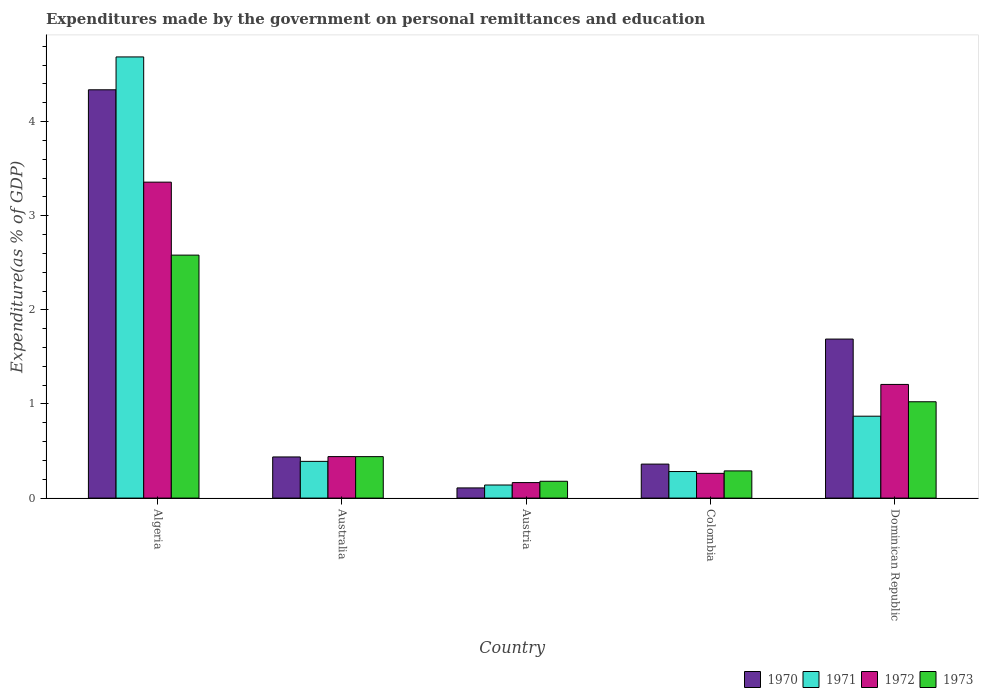Are the number of bars on each tick of the X-axis equal?
Provide a short and direct response. Yes. How many bars are there on the 1st tick from the left?
Offer a terse response. 4. In how many cases, is the number of bars for a given country not equal to the number of legend labels?
Make the answer very short. 0. What is the expenditures made by the government on personal remittances and education in 1971 in Colombia?
Your response must be concise. 0.28. Across all countries, what is the maximum expenditures made by the government on personal remittances and education in 1971?
Give a very brief answer. 4.69. Across all countries, what is the minimum expenditures made by the government on personal remittances and education in 1972?
Keep it short and to the point. 0.16. In which country was the expenditures made by the government on personal remittances and education in 1971 maximum?
Make the answer very short. Algeria. In which country was the expenditures made by the government on personal remittances and education in 1972 minimum?
Provide a succinct answer. Austria. What is the total expenditures made by the government on personal remittances and education in 1971 in the graph?
Give a very brief answer. 6.37. What is the difference between the expenditures made by the government on personal remittances and education in 1970 in Austria and that in Dominican Republic?
Offer a very short reply. -1.58. What is the difference between the expenditures made by the government on personal remittances and education in 1971 in Algeria and the expenditures made by the government on personal remittances and education in 1973 in Australia?
Keep it short and to the point. 4.25. What is the average expenditures made by the government on personal remittances and education in 1972 per country?
Make the answer very short. 1.09. What is the difference between the expenditures made by the government on personal remittances and education of/in 1970 and expenditures made by the government on personal remittances and education of/in 1972 in Algeria?
Give a very brief answer. 0.98. In how many countries, is the expenditures made by the government on personal remittances and education in 1971 greater than 3.6 %?
Provide a short and direct response. 1. What is the ratio of the expenditures made by the government on personal remittances and education in 1970 in Algeria to that in Dominican Republic?
Provide a short and direct response. 2.57. Is the expenditures made by the government on personal remittances and education in 1971 in Australia less than that in Colombia?
Give a very brief answer. No. Is the difference between the expenditures made by the government on personal remittances and education in 1970 in Algeria and Austria greater than the difference between the expenditures made by the government on personal remittances and education in 1972 in Algeria and Austria?
Ensure brevity in your answer.  Yes. What is the difference between the highest and the second highest expenditures made by the government on personal remittances and education in 1972?
Give a very brief answer. -0.77. What is the difference between the highest and the lowest expenditures made by the government on personal remittances and education in 1972?
Provide a succinct answer. 3.19. Is the sum of the expenditures made by the government on personal remittances and education in 1973 in Colombia and Dominican Republic greater than the maximum expenditures made by the government on personal remittances and education in 1970 across all countries?
Ensure brevity in your answer.  No. Is it the case that in every country, the sum of the expenditures made by the government on personal remittances and education in 1972 and expenditures made by the government on personal remittances and education in 1970 is greater than the expenditures made by the government on personal remittances and education in 1973?
Give a very brief answer. Yes. Are all the bars in the graph horizontal?
Your answer should be very brief. No. What is the difference between two consecutive major ticks on the Y-axis?
Offer a very short reply. 1. Does the graph contain any zero values?
Give a very brief answer. No. Does the graph contain grids?
Keep it short and to the point. No. How are the legend labels stacked?
Provide a succinct answer. Horizontal. What is the title of the graph?
Your response must be concise. Expenditures made by the government on personal remittances and education. What is the label or title of the X-axis?
Your answer should be very brief. Country. What is the label or title of the Y-axis?
Keep it short and to the point. Expenditure(as % of GDP). What is the Expenditure(as % of GDP) in 1970 in Algeria?
Provide a short and direct response. 4.34. What is the Expenditure(as % of GDP) in 1971 in Algeria?
Make the answer very short. 4.69. What is the Expenditure(as % of GDP) in 1972 in Algeria?
Offer a terse response. 3.36. What is the Expenditure(as % of GDP) in 1973 in Algeria?
Make the answer very short. 2.58. What is the Expenditure(as % of GDP) in 1970 in Australia?
Offer a terse response. 0.44. What is the Expenditure(as % of GDP) of 1971 in Australia?
Offer a terse response. 0.39. What is the Expenditure(as % of GDP) in 1972 in Australia?
Make the answer very short. 0.44. What is the Expenditure(as % of GDP) of 1973 in Australia?
Your response must be concise. 0.44. What is the Expenditure(as % of GDP) in 1970 in Austria?
Give a very brief answer. 0.11. What is the Expenditure(as % of GDP) in 1971 in Austria?
Offer a very short reply. 0.14. What is the Expenditure(as % of GDP) of 1972 in Austria?
Your answer should be very brief. 0.16. What is the Expenditure(as % of GDP) in 1973 in Austria?
Offer a terse response. 0.18. What is the Expenditure(as % of GDP) of 1970 in Colombia?
Offer a terse response. 0.36. What is the Expenditure(as % of GDP) in 1971 in Colombia?
Keep it short and to the point. 0.28. What is the Expenditure(as % of GDP) of 1972 in Colombia?
Your answer should be compact. 0.26. What is the Expenditure(as % of GDP) in 1973 in Colombia?
Ensure brevity in your answer.  0.29. What is the Expenditure(as % of GDP) in 1970 in Dominican Republic?
Provide a short and direct response. 1.69. What is the Expenditure(as % of GDP) in 1971 in Dominican Republic?
Provide a succinct answer. 0.87. What is the Expenditure(as % of GDP) in 1972 in Dominican Republic?
Offer a terse response. 1.21. What is the Expenditure(as % of GDP) in 1973 in Dominican Republic?
Ensure brevity in your answer.  1.02. Across all countries, what is the maximum Expenditure(as % of GDP) of 1970?
Provide a short and direct response. 4.34. Across all countries, what is the maximum Expenditure(as % of GDP) in 1971?
Ensure brevity in your answer.  4.69. Across all countries, what is the maximum Expenditure(as % of GDP) of 1972?
Provide a short and direct response. 3.36. Across all countries, what is the maximum Expenditure(as % of GDP) of 1973?
Your response must be concise. 2.58. Across all countries, what is the minimum Expenditure(as % of GDP) of 1970?
Your response must be concise. 0.11. Across all countries, what is the minimum Expenditure(as % of GDP) in 1971?
Keep it short and to the point. 0.14. Across all countries, what is the minimum Expenditure(as % of GDP) in 1972?
Keep it short and to the point. 0.16. Across all countries, what is the minimum Expenditure(as % of GDP) in 1973?
Make the answer very short. 0.18. What is the total Expenditure(as % of GDP) in 1970 in the graph?
Provide a succinct answer. 6.93. What is the total Expenditure(as % of GDP) of 1971 in the graph?
Your response must be concise. 6.37. What is the total Expenditure(as % of GDP) in 1972 in the graph?
Provide a short and direct response. 5.43. What is the total Expenditure(as % of GDP) in 1973 in the graph?
Your answer should be very brief. 4.51. What is the difference between the Expenditure(as % of GDP) of 1970 in Algeria and that in Australia?
Provide a short and direct response. 3.9. What is the difference between the Expenditure(as % of GDP) of 1971 in Algeria and that in Australia?
Provide a short and direct response. 4.3. What is the difference between the Expenditure(as % of GDP) in 1972 in Algeria and that in Australia?
Give a very brief answer. 2.92. What is the difference between the Expenditure(as % of GDP) in 1973 in Algeria and that in Australia?
Keep it short and to the point. 2.14. What is the difference between the Expenditure(as % of GDP) of 1970 in Algeria and that in Austria?
Your answer should be compact. 4.23. What is the difference between the Expenditure(as % of GDP) in 1971 in Algeria and that in Austria?
Your answer should be very brief. 4.55. What is the difference between the Expenditure(as % of GDP) of 1972 in Algeria and that in Austria?
Make the answer very short. 3.19. What is the difference between the Expenditure(as % of GDP) of 1973 in Algeria and that in Austria?
Offer a very short reply. 2.4. What is the difference between the Expenditure(as % of GDP) in 1970 in Algeria and that in Colombia?
Your answer should be compact. 3.98. What is the difference between the Expenditure(as % of GDP) of 1971 in Algeria and that in Colombia?
Make the answer very short. 4.41. What is the difference between the Expenditure(as % of GDP) in 1972 in Algeria and that in Colombia?
Give a very brief answer. 3.09. What is the difference between the Expenditure(as % of GDP) in 1973 in Algeria and that in Colombia?
Your answer should be compact. 2.29. What is the difference between the Expenditure(as % of GDP) in 1970 in Algeria and that in Dominican Republic?
Provide a succinct answer. 2.65. What is the difference between the Expenditure(as % of GDP) of 1971 in Algeria and that in Dominican Republic?
Ensure brevity in your answer.  3.82. What is the difference between the Expenditure(as % of GDP) in 1972 in Algeria and that in Dominican Republic?
Keep it short and to the point. 2.15. What is the difference between the Expenditure(as % of GDP) of 1973 in Algeria and that in Dominican Republic?
Offer a terse response. 1.56. What is the difference between the Expenditure(as % of GDP) of 1970 in Australia and that in Austria?
Your response must be concise. 0.33. What is the difference between the Expenditure(as % of GDP) of 1971 in Australia and that in Austria?
Offer a very short reply. 0.25. What is the difference between the Expenditure(as % of GDP) of 1972 in Australia and that in Austria?
Make the answer very short. 0.28. What is the difference between the Expenditure(as % of GDP) in 1973 in Australia and that in Austria?
Ensure brevity in your answer.  0.26. What is the difference between the Expenditure(as % of GDP) in 1970 in Australia and that in Colombia?
Offer a terse response. 0.08. What is the difference between the Expenditure(as % of GDP) of 1971 in Australia and that in Colombia?
Your response must be concise. 0.11. What is the difference between the Expenditure(as % of GDP) in 1972 in Australia and that in Colombia?
Offer a very short reply. 0.18. What is the difference between the Expenditure(as % of GDP) of 1973 in Australia and that in Colombia?
Provide a succinct answer. 0.15. What is the difference between the Expenditure(as % of GDP) in 1970 in Australia and that in Dominican Republic?
Give a very brief answer. -1.25. What is the difference between the Expenditure(as % of GDP) of 1971 in Australia and that in Dominican Republic?
Ensure brevity in your answer.  -0.48. What is the difference between the Expenditure(as % of GDP) in 1972 in Australia and that in Dominican Republic?
Keep it short and to the point. -0.77. What is the difference between the Expenditure(as % of GDP) in 1973 in Australia and that in Dominican Republic?
Ensure brevity in your answer.  -0.58. What is the difference between the Expenditure(as % of GDP) in 1970 in Austria and that in Colombia?
Keep it short and to the point. -0.25. What is the difference between the Expenditure(as % of GDP) of 1971 in Austria and that in Colombia?
Your answer should be compact. -0.14. What is the difference between the Expenditure(as % of GDP) of 1972 in Austria and that in Colombia?
Your answer should be very brief. -0.1. What is the difference between the Expenditure(as % of GDP) in 1973 in Austria and that in Colombia?
Your response must be concise. -0.11. What is the difference between the Expenditure(as % of GDP) of 1970 in Austria and that in Dominican Republic?
Give a very brief answer. -1.58. What is the difference between the Expenditure(as % of GDP) in 1971 in Austria and that in Dominican Republic?
Your answer should be compact. -0.73. What is the difference between the Expenditure(as % of GDP) in 1972 in Austria and that in Dominican Republic?
Give a very brief answer. -1.04. What is the difference between the Expenditure(as % of GDP) in 1973 in Austria and that in Dominican Republic?
Your answer should be very brief. -0.84. What is the difference between the Expenditure(as % of GDP) of 1970 in Colombia and that in Dominican Republic?
Provide a succinct answer. -1.33. What is the difference between the Expenditure(as % of GDP) of 1971 in Colombia and that in Dominican Republic?
Keep it short and to the point. -0.59. What is the difference between the Expenditure(as % of GDP) of 1972 in Colombia and that in Dominican Republic?
Offer a very short reply. -0.94. What is the difference between the Expenditure(as % of GDP) of 1973 in Colombia and that in Dominican Republic?
Your answer should be compact. -0.73. What is the difference between the Expenditure(as % of GDP) of 1970 in Algeria and the Expenditure(as % of GDP) of 1971 in Australia?
Give a very brief answer. 3.95. What is the difference between the Expenditure(as % of GDP) of 1970 in Algeria and the Expenditure(as % of GDP) of 1972 in Australia?
Offer a terse response. 3.9. What is the difference between the Expenditure(as % of GDP) in 1970 in Algeria and the Expenditure(as % of GDP) in 1973 in Australia?
Your answer should be compact. 3.9. What is the difference between the Expenditure(as % of GDP) of 1971 in Algeria and the Expenditure(as % of GDP) of 1972 in Australia?
Ensure brevity in your answer.  4.25. What is the difference between the Expenditure(as % of GDP) of 1971 in Algeria and the Expenditure(as % of GDP) of 1973 in Australia?
Offer a terse response. 4.25. What is the difference between the Expenditure(as % of GDP) of 1972 in Algeria and the Expenditure(as % of GDP) of 1973 in Australia?
Provide a succinct answer. 2.92. What is the difference between the Expenditure(as % of GDP) in 1970 in Algeria and the Expenditure(as % of GDP) in 1971 in Austria?
Offer a terse response. 4.2. What is the difference between the Expenditure(as % of GDP) of 1970 in Algeria and the Expenditure(as % of GDP) of 1972 in Austria?
Your response must be concise. 4.17. What is the difference between the Expenditure(as % of GDP) in 1970 in Algeria and the Expenditure(as % of GDP) in 1973 in Austria?
Your answer should be compact. 4.16. What is the difference between the Expenditure(as % of GDP) in 1971 in Algeria and the Expenditure(as % of GDP) in 1972 in Austria?
Give a very brief answer. 4.52. What is the difference between the Expenditure(as % of GDP) in 1971 in Algeria and the Expenditure(as % of GDP) in 1973 in Austria?
Give a very brief answer. 4.51. What is the difference between the Expenditure(as % of GDP) of 1972 in Algeria and the Expenditure(as % of GDP) of 1973 in Austria?
Offer a very short reply. 3.18. What is the difference between the Expenditure(as % of GDP) in 1970 in Algeria and the Expenditure(as % of GDP) in 1971 in Colombia?
Ensure brevity in your answer.  4.06. What is the difference between the Expenditure(as % of GDP) in 1970 in Algeria and the Expenditure(as % of GDP) in 1972 in Colombia?
Your response must be concise. 4.08. What is the difference between the Expenditure(as % of GDP) of 1970 in Algeria and the Expenditure(as % of GDP) of 1973 in Colombia?
Your answer should be very brief. 4.05. What is the difference between the Expenditure(as % of GDP) of 1971 in Algeria and the Expenditure(as % of GDP) of 1972 in Colombia?
Keep it short and to the point. 4.42. What is the difference between the Expenditure(as % of GDP) in 1971 in Algeria and the Expenditure(as % of GDP) in 1973 in Colombia?
Offer a very short reply. 4.4. What is the difference between the Expenditure(as % of GDP) in 1972 in Algeria and the Expenditure(as % of GDP) in 1973 in Colombia?
Provide a short and direct response. 3.07. What is the difference between the Expenditure(as % of GDP) of 1970 in Algeria and the Expenditure(as % of GDP) of 1971 in Dominican Republic?
Your answer should be compact. 3.47. What is the difference between the Expenditure(as % of GDP) in 1970 in Algeria and the Expenditure(as % of GDP) in 1972 in Dominican Republic?
Ensure brevity in your answer.  3.13. What is the difference between the Expenditure(as % of GDP) in 1970 in Algeria and the Expenditure(as % of GDP) in 1973 in Dominican Republic?
Offer a very short reply. 3.31. What is the difference between the Expenditure(as % of GDP) of 1971 in Algeria and the Expenditure(as % of GDP) of 1972 in Dominican Republic?
Your answer should be compact. 3.48. What is the difference between the Expenditure(as % of GDP) of 1971 in Algeria and the Expenditure(as % of GDP) of 1973 in Dominican Republic?
Your response must be concise. 3.66. What is the difference between the Expenditure(as % of GDP) of 1972 in Algeria and the Expenditure(as % of GDP) of 1973 in Dominican Republic?
Keep it short and to the point. 2.33. What is the difference between the Expenditure(as % of GDP) of 1970 in Australia and the Expenditure(as % of GDP) of 1971 in Austria?
Offer a very short reply. 0.3. What is the difference between the Expenditure(as % of GDP) in 1970 in Australia and the Expenditure(as % of GDP) in 1972 in Austria?
Your answer should be compact. 0.27. What is the difference between the Expenditure(as % of GDP) in 1970 in Australia and the Expenditure(as % of GDP) in 1973 in Austria?
Provide a succinct answer. 0.26. What is the difference between the Expenditure(as % of GDP) of 1971 in Australia and the Expenditure(as % of GDP) of 1972 in Austria?
Give a very brief answer. 0.23. What is the difference between the Expenditure(as % of GDP) of 1971 in Australia and the Expenditure(as % of GDP) of 1973 in Austria?
Give a very brief answer. 0.21. What is the difference between the Expenditure(as % of GDP) in 1972 in Australia and the Expenditure(as % of GDP) in 1973 in Austria?
Make the answer very short. 0.26. What is the difference between the Expenditure(as % of GDP) in 1970 in Australia and the Expenditure(as % of GDP) in 1971 in Colombia?
Your answer should be compact. 0.15. What is the difference between the Expenditure(as % of GDP) in 1970 in Australia and the Expenditure(as % of GDP) in 1972 in Colombia?
Your response must be concise. 0.17. What is the difference between the Expenditure(as % of GDP) in 1970 in Australia and the Expenditure(as % of GDP) in 1973 in Colombia?
Offer a terse response. 0.15. What is the difference between the Expenditure(as % of GDP) in 1971 in Australia and the Expenditure(as % of GDP) in 1972 in Colombia?
Provide a succinct answer. 0.13. What is the difference between the Expenditure(as % of GDP) in 1971 in Australia and the Expenditure(as % of GDP) in 1973 in Colombia?
Ensure brevity in your answer.  0.1. What is the difference between the Expenditure(as % of GDP) of 1972 in Australia and the Expenditure(as % of GDP) of 1973 in Colombia?
Ensure brevity in your answer.  0.15. What is the difference between the Expenditure(as % of GDP) of 1970 in Australia and the Expenditure(as % of GDP) of 1971 in Dominican Republic?
Provide a short and direct response. -0.43. What is the difference between the Expenditure(as % of GDP) of 1970 in Australia and the Expenditure(as % of GDP) of 1972 in Dominican Republic?
Your answer should be compact. -0.77. What is the difference between the Expenditure(as % of GDP) of 1970 in Australia and the Expenditure(as % of GDP) of 1973 in Dominican Republic?
Make the answer very short. -0.59. What is the difference between the Expenditure(as % of GDP) of 1971 in Australia and the Expenditure(as % of GDP) of 1972 in Dominican Republic?
Ensure brevity in your answer.  -0.82. What is the difference between the Expenditure(as % of GDP) in 1971 in Australia and the Expenditure(as % of GDP) in 1973 in Dominican Republic?
Your response must be concise. -0.63. What is the difference between the Expenditure(as % of GDP) in 1972 in Australia and the Expenditure(as % of GDP) in 1973 in Dominican Republic?
Offer a very short reply. -0.58. What is the difference between the Expenditure(as % of GDP) in 1970 in Austria and the Expenditure(as % of GDP) in 1971 in Colombia?
Ensure brevity in your answer.  -0.17. What is the difference between the Expenditure(as % of GDP) in 1970 in Austria and the Expenditure(as % of GDP) in 1972 in Colombia?
Make the answer very short. -0.15. What is the difference between the Expenditure(as % of GDP) of 1970 in Austria and the Expenditure(as % of GDP) of 1973 in Colombia?
Your answer should be compact. -0.18. What is the difference between the Expenditure(as % of GDP) in 1971 in Austria and the Expenditure(as % of GDP) in 1972 in Colombia?
Offer a terse response. -0.12. What is the difference between the Expenditure(as % of GDP) in 1971 in Austria and the Expenditure(as % of GDP) in 1973 in Colombia?
Your answer should be very brief. -0.15. What is the difference between the Expenditure(as % of GDP) of 1972 in Austria and the Expenditure(as % of GDP) of 1973 in Colombia?
Provide a short and direct response. -0.12. What is the difference between the Expenditure(as % of GDP) in 1970 in Austria and the Expenditure(as % of GDP) in 1971 in Dominican Republic?
Provide a short and direct response. -0.76. What is the difference between the Expenditure(as % of GDP) of 1970 in Austria and the Expenditure(as % of GDP) of 1972 in Dominican Republic?
Provide a short and direct response. -1.1. What is the difference between the Expenditure(as % of GDP) in 1970 in Austria and the Expenditure(as % of GDP) in 1973 in Dominican Republic?
Offer a terse response. -0.92. What is the difference between the Expenditure(as % of GDP) in 1971 in Austria and the Expenditure(as % of GDP) in 1972 in Dominican Republic?
Your answer should be very brief. -1.07. What is the difference between the Expenditure(as % of GDP) of 1971 in Austria and the Expenditure(as % of GDP) of 1973 in Dominican Republic?
Ensure brevity in your answer.  -0.88. What is the difference between the Expenditure(as % of GDP) in 1972 in Austria and the Expenditure(as % of GDP) in 1973 in Dominican Republic?
Give a very brief answer. -0.86. What is the difference between the Expenditure(as % of GDP) of 1970 in Colombia and the Expenditure(as % of GDP) of 1971 in Dominican Republic?
Offer a terse response. -0.51. What is the difference between the Expenditure(as % of GDP) of 1970 in Colombia and the Expenditure(as % of GDP) of 1972 in Dominican Republic?
Your response must be concise. -0.85. What is the difference between the Expenditure(as % of GDP) of 1970 in Colombia and the Expenditure(as % of GDP) of 1973 in Dominican Republic?
Ensure brevity in your answer.  -0.66. What is the difference between the Expenditure(as % of GDP) in 1971 in Colombia and the Expenditure(as % of GDP) in 1972 in Dominican Republic?
Provide a short and direct response. -0.93. What is the difference between the Expenditure(as % of GDP) of 1971 in Colombia and the Expenditure(as % of GDP) of 1973 in Dominican Republic?
Ensure brevity in your answer.  -0.74. What is the difference between the Expenditure(as % of GDP) in 1972 in Colombia and the Expenditure(as % of GDP) in 1973 in Dominican Republic?
Your answer should be compact. -0.76. What is the average Expenditure(as % of GDP) in 1970 per country?
Provide a succinct answer. 1.39. What is the average Expenditure(as % of GDP) in 1971 per country?
Keep it short and to the point. 1.27. What is the average Expenditure(as % of GDP) in 1972 per country?
Offer a terse response. 1.09. What is the average Expenditure(as % of GDP) of 1973 per country?
Give a very brief answer. 0.9. What is the difference between the Expenditure(as % of GDP) of 1970 and Expenditure(as % of GDP) of 1971 in Algeria?
Offer a terse response. -0.35. What is the difference between the Expenditure(as % of GDP) of 1970 and Expenditure(as % of GDP) of 1972 in Algeria?
Your answer should be very brief. 0.98. What is the difference between the Expenditure(as % of GDP) in 1970 and Expenditure(as % of GDP) in 1973 in Algeria?
Your answer should be compact. 1.76. What is the difference between the Expenditure(as % of GDP) of 1971 and Expenditure(as % of GDP) of 1972 in Algeria?
Offer a very short reply. 1.33. What is the difference between the Expenditure(as % of GDP) of 1971 and Expenditure(as % of GDP) of 1973 in Algeria?
Your answer should be compact. 2.11. What is the difference between the Expenditure(as % of GDP) of 1972 and Expenditure(as % of GDP) of 1973 in Algeria?
Your response must be concise. 0.78. What is the difference between the Expenditure(as % of GDP) in 1970 and Expenditure(as % of GDP) in 1971 in Australia?
Your response must be concise. 0.05. What is the difference between the Expenditure(as % of GDP) of 1970 and Expenditure(as % of GDP) of 1972 in Australia?
Your answer should be compact. -0. What is the difference between the Expenditure(as % of GDP) of 1970 and Expenditure(as % of GDP) of 1973 in Australia?
Ensure brevity in your answer.  -0. What is the difference between the Expenditure(as % of GDP) in 1971 and Expenditure(as % of GDP) in 1972 in Australia?
Provide a succinct answer. -0.05. What is the difference between the Expenditure(as % of GDP) in 1971 and Expenditure(as % of GDP) in 1973 in Australia?
Make the answer very short. -0.05. What is the difference between the Expenditure(as % of GDP) in 1972 and Expenditure(as % of GDP) in 1973 in Australia?
Provide a succinct answer. 0. What is the difference between the Expenditure(as % of GDP) in 1970 and Expenditure(as % of GDP) in 1971 in Austria?
Your answer should be compact. -0.03. What is the difference between the Expenditure(as % of GDP) in 1970 and Expenditure(as % of GDP) in 1972 in Austria?
Your response must be concise. -0.06. What is the difference between the Expenditure(as % of GDP) in 1970 and Expenditure(as % of GDP) in 1973 in Austria?
Ensure brevity in your answer.  -0.07. What is the difference between the Expenditure(as % of GDP) in 1971 and Expenditure(as % of GDP) in 1972 in Austria?
Provide a succinct answer. -0.03. What is the difference between the Expenditure(as % of GDP) in 1971 and Expenditure(as % of GDP) in 1973 in Austria?
Make the answer very short. -0.04. What is the difference between the Expenditure(as % of GDP) in 1972 and Expenditure(as % of GDP) in 1973 in Austria?
Offer a very short reply. -0.01. What is the difference between the Expenditure(as % of GDP) in 1970 and Expenditure(as % of GDP) in 1971 in Colombia?
Offer a terse response. 0.08. What is the difference between the Expenditure(as % of GDP) of 1970 and Expenditure(as % of GDP) of 1972 in Colombia?
Offer a terse response. 0.1. What is the difference between the Expenditure(as % of GDP) of 1970 and Expenditure(as % of GDP) of 1973 in Colombia?
Your answer should be very brief. 0.07. What is the difference between the Expenditure(as % of GDP) of 1971 and Expenditure(as % of GDP) of 1972 in Colombia?
Your response must be concise. 0.02. What is the difference between the Expenditure(as % of GDP) of 1971 and Expenditure(as % of GDP) of 1973 in Colombia?
Your answer should be compact. -0.01. What is the difference between the Expenditure(as % of GDP) of 1972 and Expenditure(as % of GDP) of 1973 in Colombia?
Offer a terse response. -0.03. What is the difference between the Expenditure(as % of GDP) in 1970 and Expenditure(as % of GDP) in 1971 in Dominican Republic?
Your answer should be very brief. 0.82. What is the difference between the Expenditure(as % of GDP) in 1970 and Expenditure(as % of GDP) in 1972 in Dominican Republic?
Your answer should be compact. 0.48. What is the difference between the Expenditure(as % of GDP) in 1970 and Expenditure(as % of GDP) in 1973 in Dominican Republic?
Make the answer very short. 0.67. What is the difference between the Expenditure(as % of GDP) of 1971 and Expenditure(as % of GDP) of 1972 in Dominican Republic?
Provide a short and direct response. -0.34. What is the difference between the Expenditure(as % of GDP) of 1971 and Expenditure(as % of GDP) of 1973 in Dominican Republic?
Make the answer very short. -0.15. What is the difference between the Expenditure(as % of GDP) of 1972 and Expenditure(as % of GDP) of 1973 in Dominican Republic?
Give a very brief answer. 0.18. What is the ratio of the Expenditure(as % of GDP) in 1970 in Algeria to that in Australia?
Ensure brevity in your answer.  9.92. What is the ratio of the Expenditure(as % of GDP) in 1971 in Algeria to that in Australia?
Give a very brief answer. 12.01. What is the ratio of the Expenditure(as % of GDP) of 1972 in Algeria to that in Australia?
Ensure brevity in your answer.  7.61. What is the ratio of the Expenditure(as % of GDP) in 1973 in Algeria to that in Australia?
Offer a very short reply. 5.86. What is the ratio of the Expenditure(as % of GDP) of 1970 in Algeria to that in Austria?
Provide a short and direct response. 40.14. What is the ratio of the Expenditure(as % of GDP) of 1971 in Algeria to that in Austria?
Keep it short and to the point. 33.73. What is the ratio of the Expenditure(as % of GDP) of 1972 in Algeria to that in Austria?
Give a very brief answer. 20.38. What is the ratio of the Expenditure(as % of GDP) of 1973 in Algeria to that in Austria?
Your answer should be compact. 14.45. What is the ratio of the Expenditure(as % of GDP) of 1970 in Algeria to that in Colombia?
Your answer should be very brief. 12.01. What is the ratio of the Expenditure(as % of GDP) in 1971 in Algeria to that in Colombia?
Offer a terse response. 16.61. What is the ratio of the Expenditure(as % of GDP) in 1972 in Algeria to that in Colombia?
Provide a succinct answer. 12.77. What is the ratio of the Expenditure(as % of GDP) in 1973 in Algeria to that in Colombia?
Your response must be concise. 8.94. What is the ratio of the Expenditure(as % of GDP) in 1970 in Algeria to that in Dominican Republic?
Give a very brief answer. 2.57. What is the ratio of the Expenditure(as % of GDP) of 1971 in Algeria to that in Dominican Republic?
Your answer should be compact. 5.39. What is the ratio of the Expenditure(as % of GDP) of 1972 in Algeria to that in Dominican Republic?
Offer a very short reply. 2.78. What is the ratio of the Expenditure(as % of GDP) of 1973 in Algeria to that in Dominican Republic?
Ensure brevity in your answer.  2.52. What is the ratio of the Expenditure(as % of GDP) of 1970 in Australia to that in Austria?
Your answer should be very brief. 4.04. What is the ratio of the Expenditure(as % of GDP) in 1971 in Australia to that in Austria?
Provide a short and direct response. 2.81. What is the ratio of the Expenditure(as % of GDP) in 1972 in Australia to that in Austria?
Your answer should be very brief. 2.68. What is the ratio of the Expenditure(as % of GDP) in 1973 in Australia to that in Austria?
Your answer should be compact. 2.47. What is the ratio of the Expenditure(as % of GDP) of 1970 in Australia to that in Colombia?
Make the answer very short. 1.21. What is the ratio of the Expenditure(as % of GDP) in 1971 in Australia to that in Colombia?
Provide a succinct answer. 1.38. What is the ratio of the Expenditure(as % of GDP) of 1972 in Australia to that in Colombia?
Your answer should be compact. 1.68. What is the ratio of the Expenditure(as % of GDP) of 1973 in Australia to that in Colombia?
Your response must be concise. 1.52. What is the ratio of the Expenditure(as % of GDP) of 1970 in Australia to that in Dominican Republic?
Provide a short and direct response. 0.26. What is the ratio of the Expenditure(as % of GDP) in 1971 in Australia to that in Dominican Republic?
Offer a very short reply. 0.45. What is the ratio of the Expenditure(as % of GDP) in 1972 in Australia to that in Dominican Republic?
Your response must be concise. 0.37. What is the ratio of the Expenditure(as % of GDP) in 1973 in Australia to that in Dominican Republic?
Your answer should be compact. 0.43. What is the ratio of the Expenditure(as % of GDP) of 1970 in Austria to that in Colombia?
Make the answer very short. 0.3. What is the ratio of the Expenditure(as % of GDP) of 1971 in Austria to that in Colombia?
Offer a terse response. 0.49. What is the ratio of the Expenditure(as % of GDP) in 1972 in Austria to that in Colombia?
Give a very brief answer. 0.63. What is the ratio of the Expenditure(as % of GDP) of 1973 in Austria to that in Colombia?
Give a very brief answer. 0.62. What is the ratio of the Expenditure(as % of GDP) of 1970 in Austria to that in Dominican Republic?
Give a very brief answer. 0.06. What is the ratio of the Expenditure(as % of GDP) in 1971 in Austria to that in Dominican Republic?
Provide a short and direct response. 0.16. What is the ratio of the Expenditure(as % of GDP) in 1972 in Austria to that in Dominican Republic?
Offer a very short reply. 0.14. What is the ratio of the Expenditure(as % of GDP) in 1973 in Austria to that in Dominican Republic?
Your response must be concise. 0.17. What is the ratio of the Expenditure(as % of GDP) in 1970 in Colombia to that in Dominican Republic?
Give a very brief answer. 0.21. What is the ratio of the Expenditure(as % of GDP) in 1971 in Colombia to that in Dominican Republic?
Your answer should be very brief. 0.32. What is the ratio of the Expenditure(as % of GDP) of 1972 in Colombia to that in Dominican Republic?
Keep it short and to the point. 0.22. What is the ratio of the Expenditure(as % of GDP) of 1973 in Colombia to that in Dominican Republic?
Provide a succinct answer. 0.28. What is the difference between the highest and the second highest Expenditure(as % of GDP) of 1970?
Offer a very short reply. 2.65. What is the difference between the highest and the second highest Expenditure(as % of GDP) of 1971?
Provide a succinct answer. 3.82. What is the difference between the highest and the second highest Expenditure(as % of GDP) in 1972?
Give a very brief answer. 2.15. What is the difference between the highest and the second highest Expenditure(as % of GDP) of 1973?
Provide a short and direct response. 1.56. What is the difference between the highest and the lowest Expenditure(as % of GDP) of 1970?
Your answer should be very brief. 4.23. What is the difference between the highest and the lowest Expenditure(as % of GDP) of 1971?
Your answer should be compact. 4.55. What is the difference between the highest and the lowest Expenditure(as % of GDP) of 1972?
Offer a terse response. 3.19. What is the difference between the highest and the lowest Expenditure(as % of GDP) in 1973?
Your answer should be very brief. 2.4. 